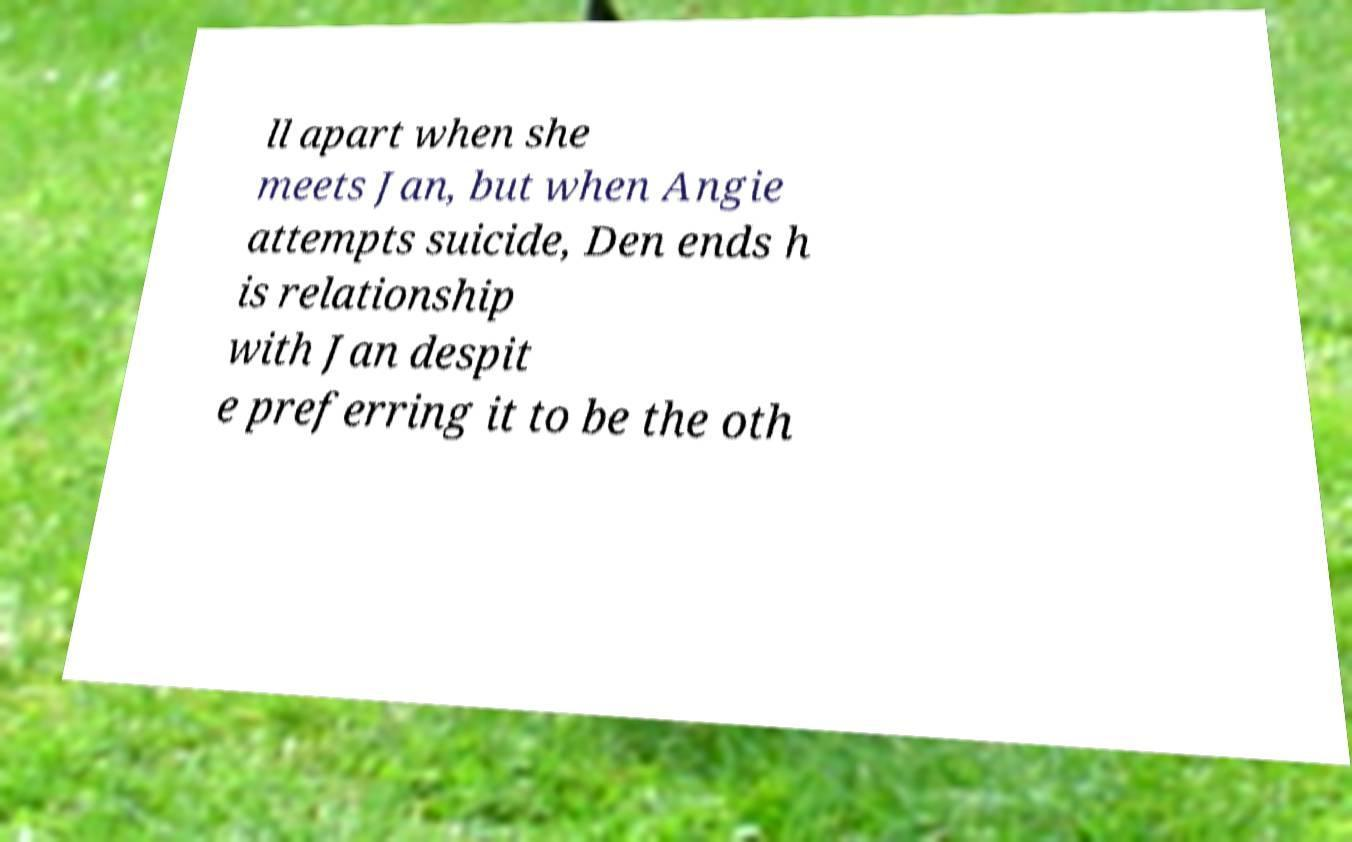Could you assist in decoding the text presented in this image and type it out clearly? ll apart when she meets Jan, but when Angie attempts suicide, Den ends h is relationship with Jan despit e preferring it to be the oth 